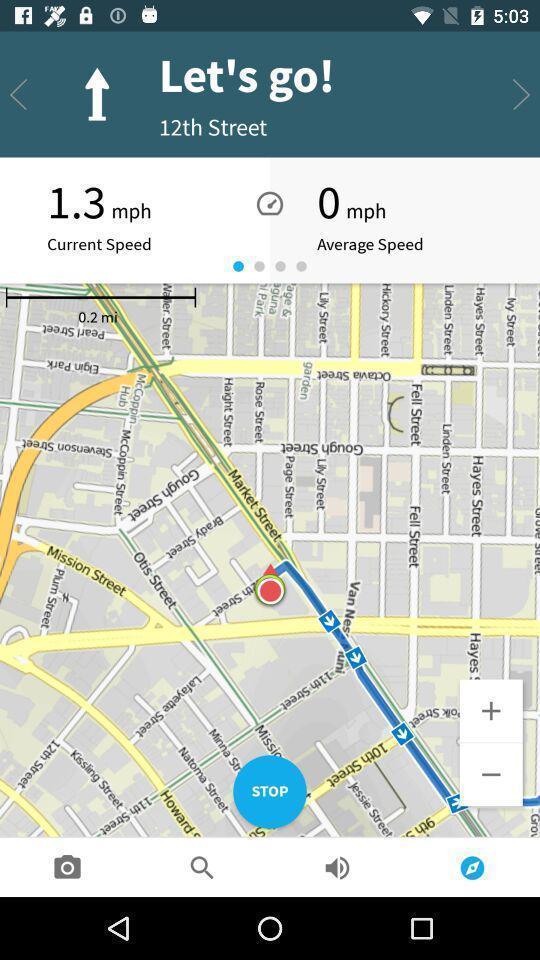What details can you identify in this image? Route map application in the mobile. 